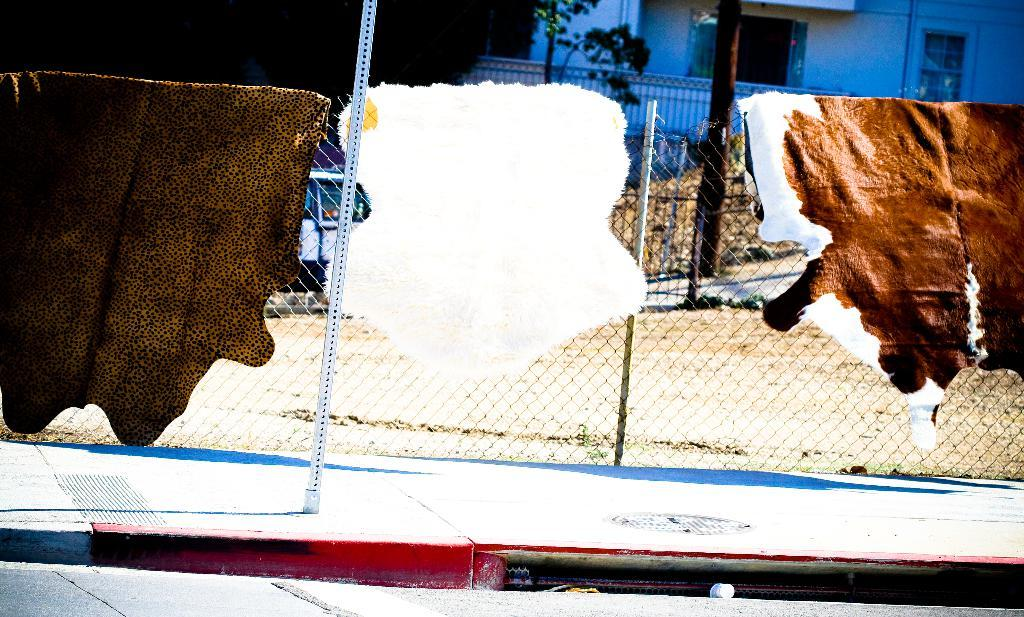What is hanging on the fence in the image? There are animal skins hung on the fence. What can be seen in the background of the image? There is a building, trees, and a vehicle in the background of the image. How many wings are visible on the animal skins in the image? There are no wings visible on the animal skins in the image, as they are skins and not living animals. What type of humor can be found in the image? There is no humor present in the image, as it is a straightforward depiction of animal skins hung on a fence and a background scene. 